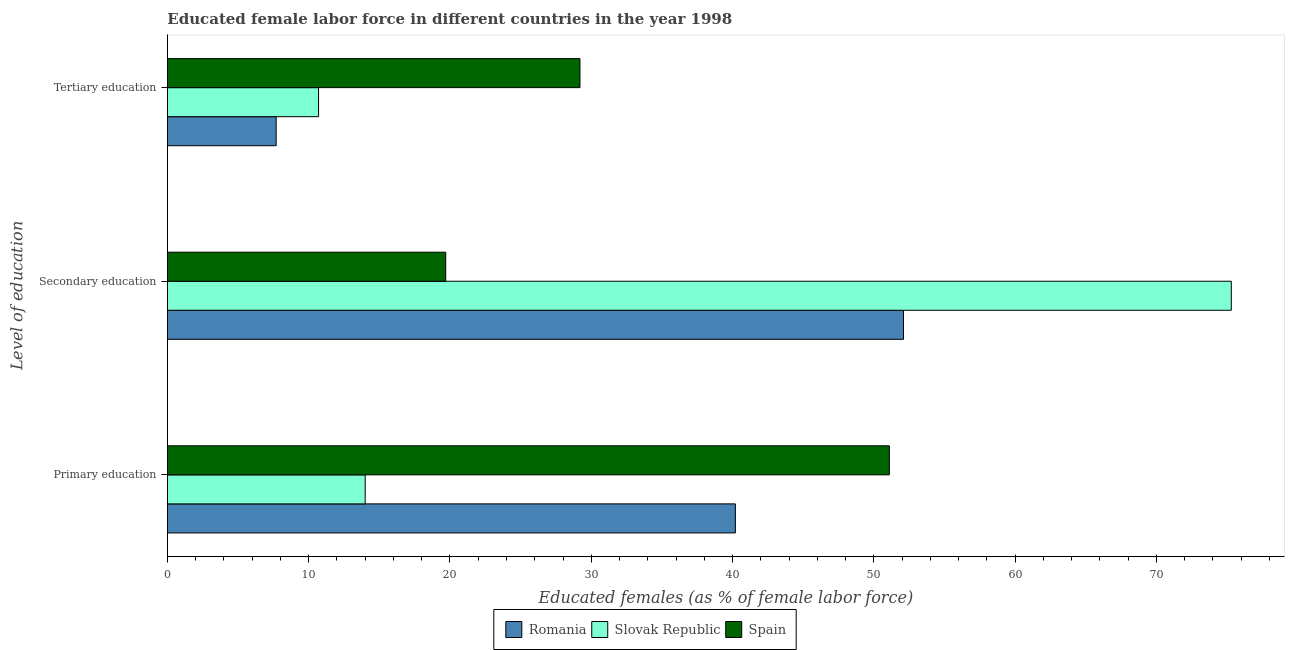How many different coloured bars are there?
Your response must be concise. 3. Are the number of bars per tick equal to the number of legend labels?
Offer a terse response. Yes. Are the number of bars on each tick of the Y-axis equal?
Offer a terse response. Yes. What is the percentage of female labor force who received tertiary education in Spain?
Provide a succinct answer. 29.2. Across all countries, what is the maximum percentage of female labor force who received tertiary education?
Provide a succinct answer. 29.2. Across all countries, what is the minimum percentage of female labor force who received secondary education?
Ensure brevity in your answer.  19.7. In which country was the percentage of female labor force who received primary education maximum?
Make the answer very short. Spain. In which country was the percentage of female labor force who received tertiary education minimum?
Provide a succinct answer. Romania. What is the total percentage of female labor force who received primary education in the graph?
Provide a succinct answer. 105.3. What is the difference between the percentage of female labor force who received secondary education in Slovak Republic and that in Romania?
Make the answer very short. 23.2. What is the difference between the percentage of female labor force who received primary education in Slovak Republic and the percentage of female labor force who received tertiary education in Romania?
Your answer should be compact. 6.3. What is the average percentage of female labor force who received secondary education per country?
Give a very brief answer. 49.03. What is the difference between the percentage of female labor force who received tertiary education and percentage of female labor force who received primary education in Spain?
Keep it short and to the point. -21.9. In how many countries, is the percentage of female labor force who received secondary education greater than 24 %?
Give a very brief answer. 2. What is the ratio of the percentage of female labor force who received secondary education in Slovak Republic to that in Spain?
Your response must be concise. 3.82. Is the percentage of female labor force who received secondary education in Slovak Republic less than that in Spain?
Ensure brevity in your answer.  No. What is the difference between the highest and the second highest percentage of female labor force who received secondary education?
Keep it short and to the point. 23.2. What is the difference between the highest and the lowest percentage of female labor force who received primary education?
Offer a very short reply. 37.1. In how many countries, is the percentage of female labor force who received primary education greater than the average percentage of female labor force who received primary education taken over all countries?
Your answer should be compact. 2. What does the 2nd bar from the bottom in Tertiary education represents?
Your answer should be very brief. Slovak Republic. Are all the bars in the graph horizontal?
Ensure brevity in your answer.  Yes. How many countries are there in the graph?
Keep it short and to the point. 3. What is the difference between two consecutive major ticks on the X-axis?
Ensure brevity in your answer.  10. Does the graph contain any zero values?
Provide a short and direct response. No. How many legend labels are there?
Offer a terse response. 3. How are the legend labels stacked?
Make the answer very short. Horizontal. What is the title of the graph?
Offer a very short reply. Educated female labor force in different countries in the year 1998. Does "Angola" appear as one of the legend labels in the graph?
Keep it short and to the point. No. What is the label or title of the X-axis?
Give a very brief answer. Educated females (as % of female labor force). What is the label or title of the Y-axis?
Keep it short and to the point. Level of education. What is the Educated females (as % of female labor force) in Romania in Primary education?
Your response must be concise. 40.2. What is the Educated females (as % of female labor force) of Spain in Primary education?
Provide a short and direct response. 51.1. What is the Educated females (as % of female labor force) of Romania in Secondary education?
Ensure brevity in your answer.  52.1. What is the Educated females (as % of female labor force) of Slovak Republic in Secondary education?
Your answer should be compact. 75.3. What is the Educated females (as % of female labor force) of Spain in Secondary education?
Your response must be concise. 19.7. What is the Educated females (as % of female labor force) in Romania in Tertiary education?
Give a very brief answer. 7.7. What is the Educated females (as % of female labor force) in Slovak Republic in Tertiary education?
Give a very brief answer. 10.7. What is the Educated females (as % of female labor force) of Spain in Tertiary education?
Your answer should be compact. 29.2. Across all Level of education, what is the maximum Educated females (as % of female labor force) of Romania?
Make the answer very short. 52.1. Across all Level of education, what is the maximum Educated females (as % of female labor force) in Slovak Republic?
Offer a very short reply. 75.3. Across all Level of education, what is the maximum Educated females (as % of female labor force) of Spain?
Your response must be concise. 51.1. Across all Level of education, what is the minimum Educated females (as % of female labor force) of Romania?
Provide a succinct answer. 7.7. Across all Level of education, what is the minimum Educated females (as % of female labor force) of Slovak Republic?
Provide a short and direct response. 10.7. Across all Level of education, what is the minimum Educated females (as % of female labor force) in Spain?
Make the answer very short. 19.7. What is the total Educated females (as % of female labor force) in Romania in the graph?
Give a very brief answer. 100. What is the total Educated females (as % of female labor force) in Slovak Republic in the graph?
Offer a very short reply. 100. What is the total Educated females (as % of female labor force) of Spain in the graph?
Give a very brief answer. 100. What is the difference between the Educated females (as % of female labor force) in Romania in Primary education and that in Secondary education?
Your response must be concise. -11.9. What is the difference between the Educated females (as % of female labor force) of Slovak Republic in Primary education and that in Secondary education?
Make the answer very short. -61.3. What is the difference between the Educated females (as % of female labor force) in Spain in Primary education and that in Secondary education?
Your response must be concise. 31.4. What is the difference between the Educated females (as % of female labor force) of Romania in Primary education and that in Tertiary education?
Provide a short and direct response. 32.5. What is the difference between the Educated females (as % of female labor force) of Spain in Primary education and that in Tertiary education?
Provide a succinct answer. 21.9. What is the difference between the Educated females (as % of female labor force) of Romania in Secondary education and that in Tertiary education?
Your answer should be compact. 44.4. What is the difference between the Educated females (as % of female labor force) in Slovak Republic in Secondary education and that in Tertiary education?
Your answer should be very brief. 64.6. What is the difference between the Educated females (as % of female labor force) of Spain in Secondary education and that in Tertiary education?
Offer a terse response. -9.5. What is the difference between the Educated females (as % of female labor force) in Romania in Primary education and the Educated females (as % of female labor force) in Slovak Republic in Secondary education?
Your response must be concise. -35.1. What is the difference between the Educated females (as % of female labor force) in Slovak Republic in Primary education and the Educated females (as % of female labor force) in Spain in Secondary education?
Keep it short and to the point. -5.7. What is the difference between the Educated females (as % of female labor force) in Romania in Primary education and the Educated females (as % of female labor force) in Slovak Republic in Tertiary education?
Offer a terse response. 29.5. What is the difference between the Educated females (as % of female labor force) in Romania in Primary education and the Educated females (as % of female labor force) in Spain in Tertiary education?
Keep it short and to the point. 11. What is the difference between the Educated females (as % of female labor force) in Slovak Republic in Primary education and the Educated females (as % of female labor force) in Spain in Tertiary education?
Offer a terse response. -15.2. What is the difference between the Educated females (as % of female labor force) of Romania in Secondary education and the Educated females (as % of female labor force) of Slovak Republic in Tertiary education?
Offer a very short reply. 41.4. What is the difference between the Educated females (as % of female labor force) in Romania in Secondary education and the Educated females (as % of female labor force) in Spain in Tertiary education?
Keep it short and to the point. 22.9. What is the difference between the Educated females (as % of female labor force) in Slovak Republic in Secondary education and the Educated females (as % of female labor force) in Spain in Tertiary education?
Keep it short and to the point. 46.1. What is the average Educated females (as % of female labor force) in Romania per Level of education?
Keep it short and to the point. 33.33. What is the average Educated females (as % of female labor force) in Slovak Republic per Level of education?
Ensure brevity in your answer.  33.33. What is the average Educated females (as % of female labor force) in Spain per Level of education?
Your answer should be very brief. 33.33. What is the difference between the Educated females (as % of female labor force) in Romania and Educated females (as % of female labor force) in Slovak Republic in Primary education?
Keep it short and to the point. 26.2. What is the difference between the Educated females (as % of female labor force) in Slovak Republic and Educated females (as % of female labor force) in Spain in Primary education?
Make the answer very short. -37.1. What is the difference between the Educated females (as % of female labor force) of Romania and Educated females (as % of female labor force) of Slovak Republic in Secondary education?
Your response must be concise. -23.2. What is the difference between the Educated females (as % of female labor force) in Romania and Educated females (as % of female labor force) in Spain in Secondary education?
Ensure brevity in your answer.  32.4. What is the difference between the Educated females (as % of female labor force) of Slovak Republic and Educated females (as % of female labor force) of Spain in Secondary education?
Your answer should be very brief. 55.6. What is the difference between the Educated females (as % of female labor force) in Romania and Educated females (as % of female labor force) in Spain in Tertiary education?
Your response must be concise. -21.5. What is the difference between the Educated females (as % of female labor force) in Slovak Republic and Educated females (as % of female labor force) in Spain in Tertiary education?
Your response must be concise. -18.5. What is the ratio of the Educated females (as % of female labor force) of Romania in Primary education to that in Secondary education?
Make the answer very short. 0.77. What is the ratio of the Educated females (as % of female labor force) in Slovak Republic in Primary education to that in Secondary education?
Provide a short and direct response. 0.19. What is the ratio of the Educated females (as % of female labor force) in Spain in Primary education to that in Secondary education?
Your response must be concise. 2.59. What is the ratio of the Educated females (as % of female labor force) in Romania in Primary education to that in Tertiary education?
Keep it short and to the point. 5.22. What is the ratio of the Educated females (as % of female labor force) of Slovak Republic in Primary education to that in Tertiary education?
Your response must be concise. 1.31. What is the ratio of the Educated females (as % of female labor force) of Spain in Primary education to that in Tertiary education?
Provide a succinct answer. 1.75. What is the ratio of the Educated females (as % of female labor force) of Romania in Secondary education to that in Tertiary education?
Provide a succinct answer. 6.77. What is the ratio of the Educated females (as % of female labor force) in Slovak Republic in Secondary education to that in Tertiary education?
Offer a terse response. 7.04. What is the ratio of the Educated females (as % of female labor force) of Spain in Secondary education to that in Tertiary education?
Ensure brevity in your answer.  0.67. What is the difference between the highest and the second highest Educated females (as % of female labor force) in Slovak Republic?
Ensure brevity in your answer.  61.3. What is the difference between the highest and the second highest Educated females (as % of female labor force) in Spain?
Your answer should be very brief. 21.9. What is the difference between the highest and the lowest Educated females (as % of female labor force) in Romania?
Ensure brevity in your answer.  44.4. What is the difference between the highest and the lowest Educated females (as % of female labor force) of Slovak Republic?
Your response must be concise. 64.6. What is the difference between the highest and the lowest Educated females (as % of female labor force) in Spain?
Your answer should be compact. 31.4. 